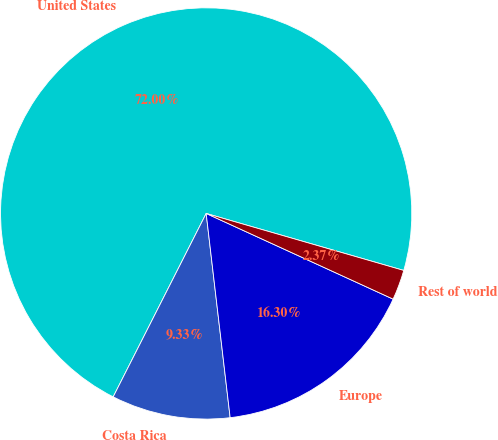<chart> <loc_0><loc_0><loc_500><loc_500><pie_chart><fcel>United States<fcel>Costa Rica<fcel>Europe<fcel>Rest of world<nl><fcel>72.0%<fcel>9.33%<fcel>16.3%<fcel>2.37%<nl></chart> 